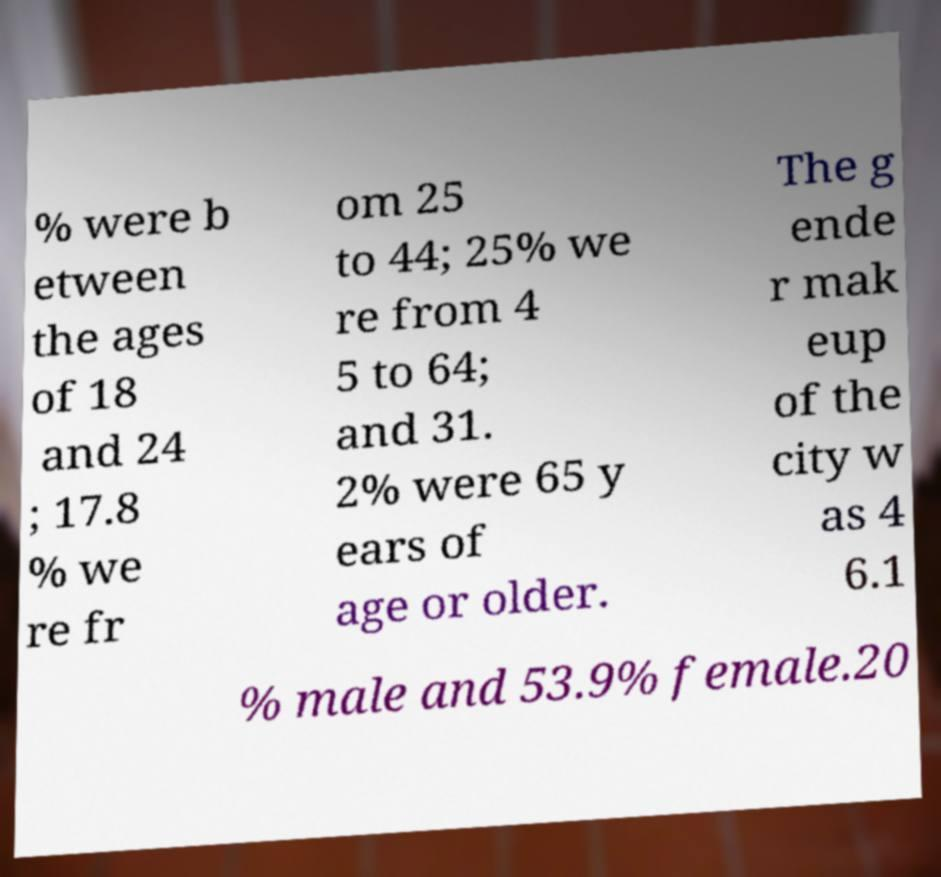Can you accurately transcribe the text from the provided image for me? % were b etween the ages of 18 and 24 ; 17.8 % we re fr om 25 to 44; 25% we re from 4 5 to 64; and 31. 2% were 65 y ears of age or older. The g ende r mak eup of the city w as 4 6.1 % male and 53.9% female.20 